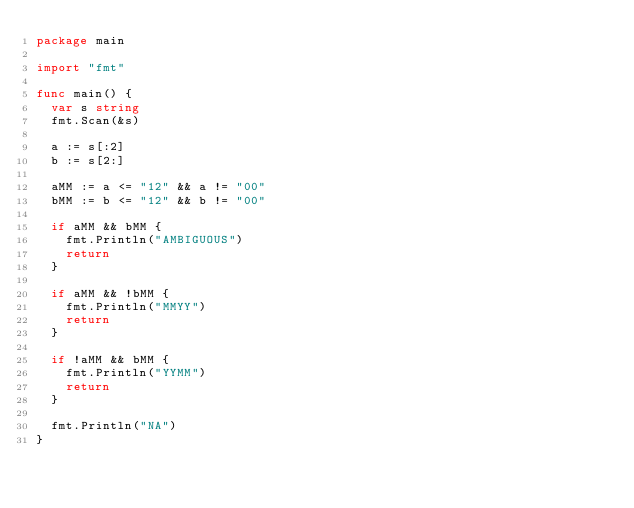<code> <loc_0><loc_0><loc_500><loc_500><_Go_>package main

import "fmt"

func main() {
	var s string
	fmt.Scan(&s)

	a := s[:2]
	b := s[2:]

	aMM := a <= "12" && a != "00"
	bMM := b <= "12" && b != "00"

	if aMM && bMM {
		fmt.Println("AMBIGUOUS")
		return
	}

	if aMM && !bMM {
		fmt.Println("MMYY")
		return
	}

	if !aMM && bMM {
		fmt.Println("YYMM")
		return
	}

	fmt.Println("NA")
}
</code> 